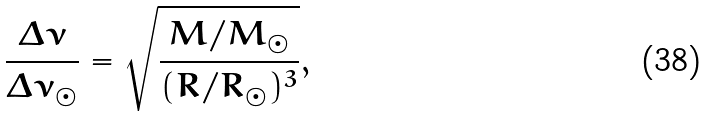<formula> <loc_0><loc_0><loc_500><loc_500>\frac { \Delta \nu } { \Delta \nu _ { \odot } } = \sqrt { \frac { M / M _ { \odot } } { ( R / R _ { \odot } ) ^ { 3 } } } ,</formula> 